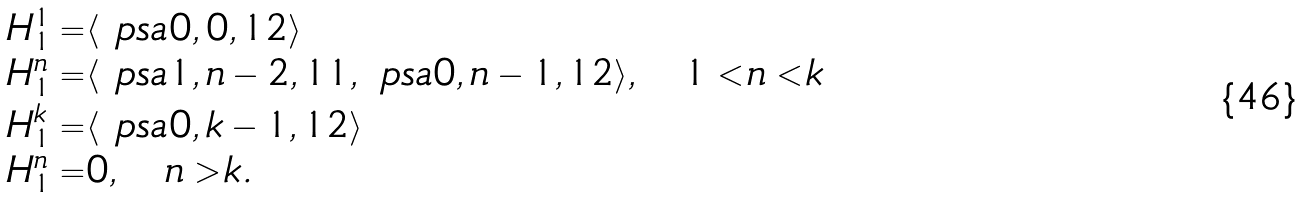Convert formula to latex. <formula><loc_0><loc_0><loc_500><loc_500>H ^ { 1 } _ { 1 } = & \langle \ p s a { 0 , 0 , 1 } 2 \rangle \\ H ^ { n } _ { 1 } = & \langle \ p s a { 1 , n - 2 , 1 } 1 , \ p s a { 0 , n - 1 , 1 } 2 \rangle , \quad 1 < n < k \\ H ^ { k } _ { 1 } = & \langle \ p s a { 0 , k - 1 , 1 } 2 \rangle \\ H ^ { n } _ { 1 } = & 0 , \quad n > k .</formula> 